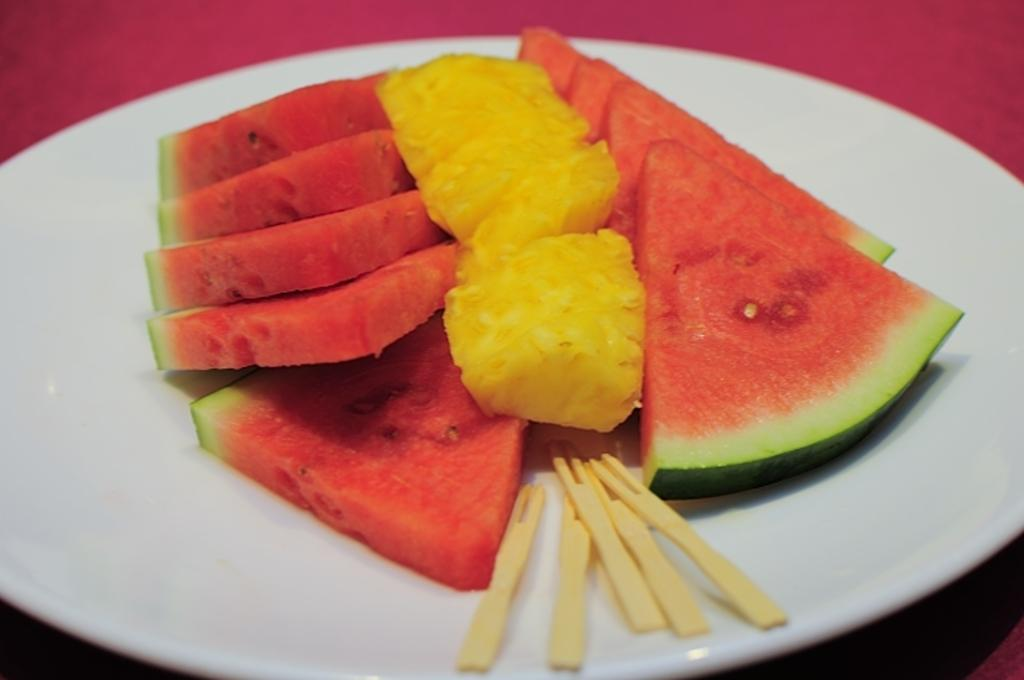What type of fruit can be seen in the image? There are pieces of watermelon and pineapple in the image. How are the pieces of fruit arranged in the image? The pieces of fruit are on a plate in the image. What is used to hold the fruit in the image? There are sticks on the plate. What color is the surface the plate is on? The plate is on a pink surface. How many trees are visible in the image? There are no trees visible in the image; it features pieces of watermelon and pineapple on a plate. What type of plot is being developed in the image? There is no plot being developed in the image; it is a still image of fruit on a plate. 